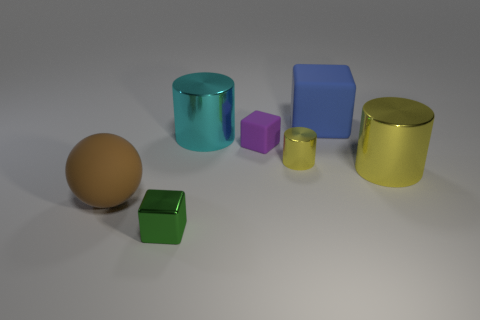How would you categorize these objects in terms of their shapes? These objects can be categorized by geometric shapes: there's a sphere, two cylinders, and three cubes. The cylinders and sphere have curved surfaces that reflect light smoothly, while the cubes have flat surfaces and sharp edges that create defined shadows. 